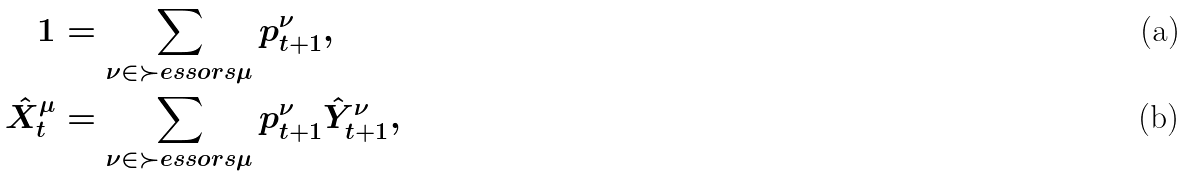<formula> <loc_0><loc_0><loc_500><loc_500>1 & = \sum _ { \nu \in \succ e s s o r s \mu } p _ { t + 1 } ^ { \nu } , \\ \hat { X } _ { t } ^ { \mu } & = \sum _ { \nu \in \succ e s s o r s \mu } p _ { t + 1 } ^ { \nu } \hat { Y } _ { t + 1 } ^ { \nu } ,</formula> 